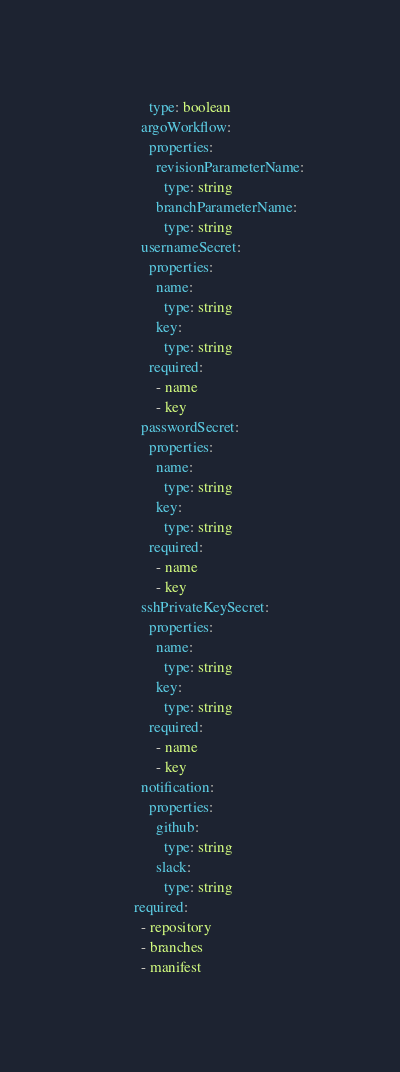Convert code to text. <code><loc_0><loc_0><loc_500><loc_500><_YAML_>              type: boolean
            argoWorkflow:
              properties:
                revisionParameterName:
                  type: string
                branchParameterName:
                  type: string
            usernameSecret:
              properties:
                name:
                  type: string
                key:
                  type: string
              required:
                - name
                - key
            passwordSecret:
              properties:
                name:
                  type: string
                key:
                  type: string
              required:
                - name
                - key
            sshPrivateKeySecret:
              properties:
                name:
                  type: string
                key:
                  type: string
              required:
                - name
                - key
            notification:
              properties:
                github:
                  type: string
                slack:
                  type: string
          required:
            - repository
            - branches
            - manifest
</code> 